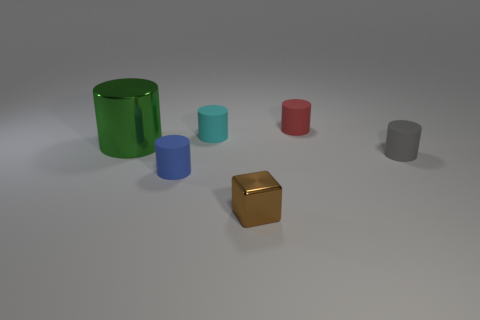Subtract all tiny gray rubber cylinders. How many cylinders are left? 4 Add 4 small gray matte cylinders. How many objects exist? 10 Subtract all red cylinders. How many cylinders are left? 4 Subtract all blocks. How many objects are left? 5 Subtract 4 cylinders. How many cylinders are left? 1 Subtract all purple cubes. How many cyan cylinders are left? 1 Add 4 green cylinders. How many green cylinders are left? 5 Add 1 small cyan rubber cylinders. How many small cyan rubber cylinders exist? 2 Subtract 0 yellow blocks. How many objects are left? 6 Subtract all blue cylinders. Subtract all purple blocks. How many cylinders are left? 4 